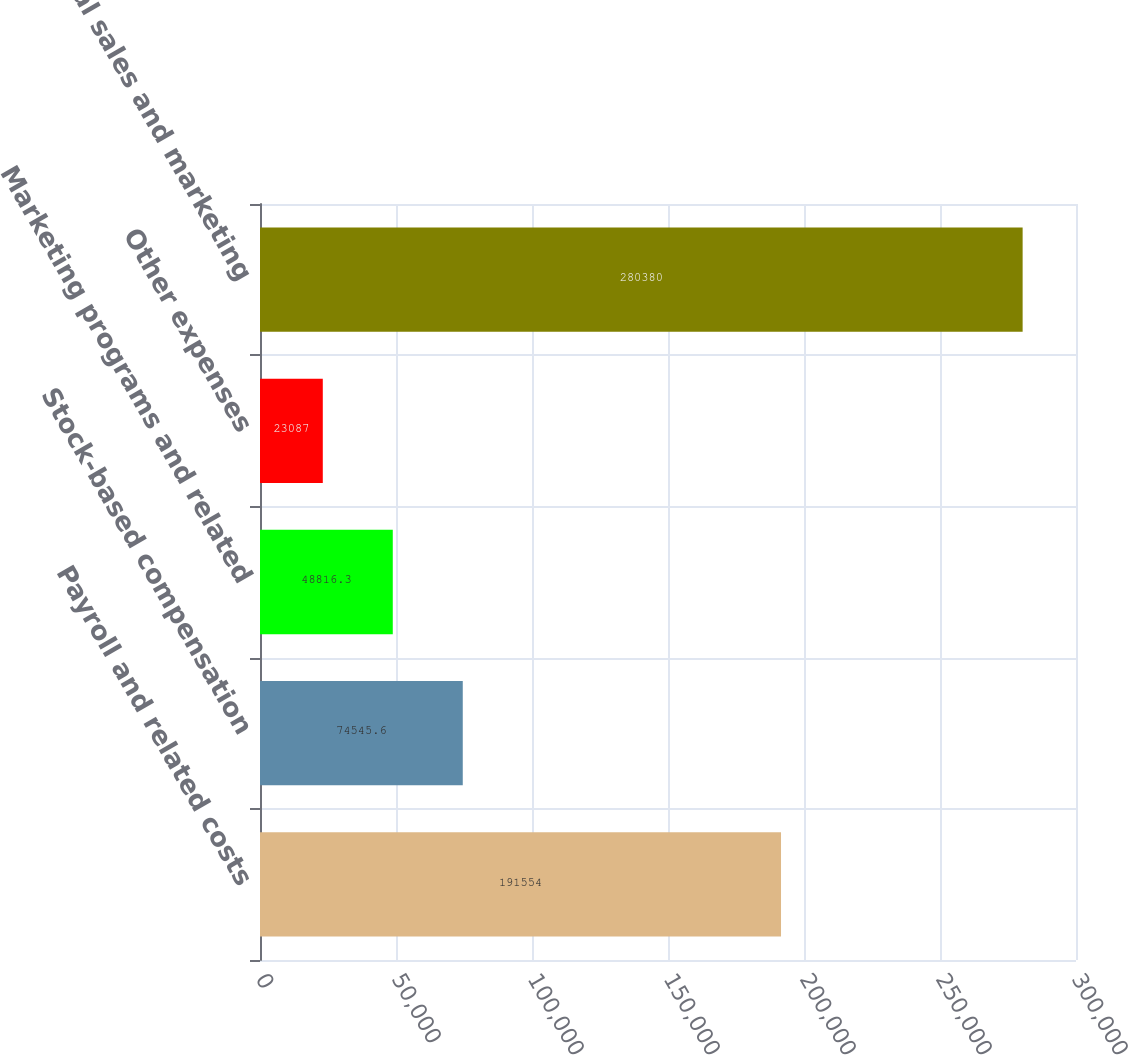Convert chart to OTSL. <chart><loc_0><loc_0><loc_500><loc_500><bar_chart><fcel>Payroll and related costs<fcel>Stock-based compensation<fcel>Marketing programs and related<fcel>Other expenses<fcel>Total sales and marketing<nl><fcel>191554<fcel>74545.6<fcel>48816.3<fcel>23087<fcel>280380<nl></chart> 